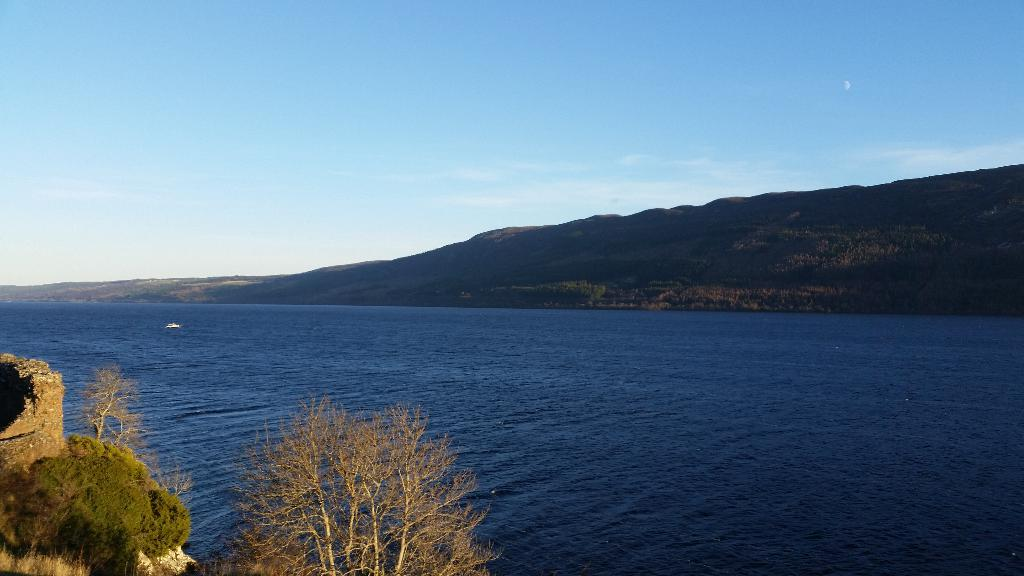What can be seen on the left side of the image? There are plants and trees on a mountain on the left side of the image. What is present on the right side of the image? There is water on the right side of the image. What is visible in the background of the image? There is a mountain in the background of the image. What can be seen in the sky in the image? There are clouds in the sky, and the sky is blue. How many pigs are swimming in the water on the right side of the image? There are no pigs present in the image; it features water on the right side. What type of animal can be seen interacting with the plants and trees on the mountain on the left side of the image? There is no animal shown interacting with the plants and trees on the mountain on the left side of the image; only plants, trees, and a mountain are present. 